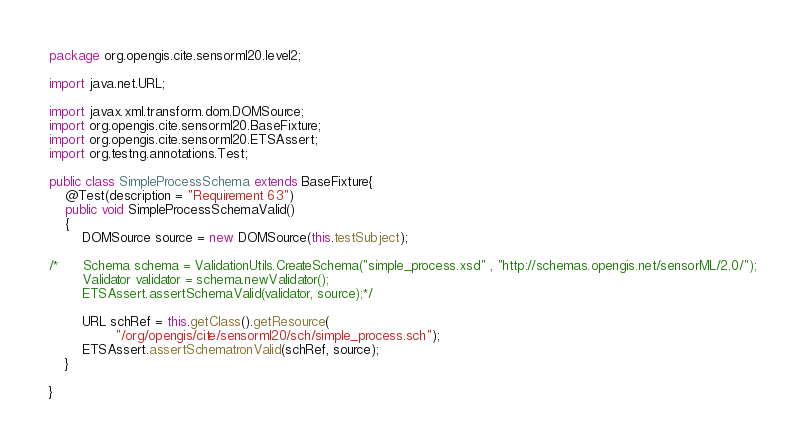Convert code to text. <code><loc_0><loc_0><loc_500><loc_500><_Java_>package org.opengis.cite.sensorml20.level2;

import java.net.URL;

import javax.xml.transform.dom.DOMSource;
import org.opengis.cite.sensorml20.BaseFixture;
import org.opengis.cite.sensorml20.ETSAssert;
import org.testng.annotations.Test;

public class SimpleProcessSchema extends BaseFixture{
	@Test(description = "Requirement 63")
	public void SimpleProcessSchemaValid()
	{
		DOMSource source = new DOMSource(this.testSubject);
	      
/*		Schema schema = ValidationUtils.CreateSchema("simple_process.xsd" , "http://schemas.opengis.net/sensorML/2.0/");
        Validator validator = schema.newValidator();
        ETSAssert.assertSchemaValid(validator, source);*/
				
		URL schRef = this.getClass().getResource(
				"/org/opengis/cite/sensorml20/sch/simple_process.sch");
		ETSAssert.assertSchematronValid(schRef, source);
	}

}
</code> 